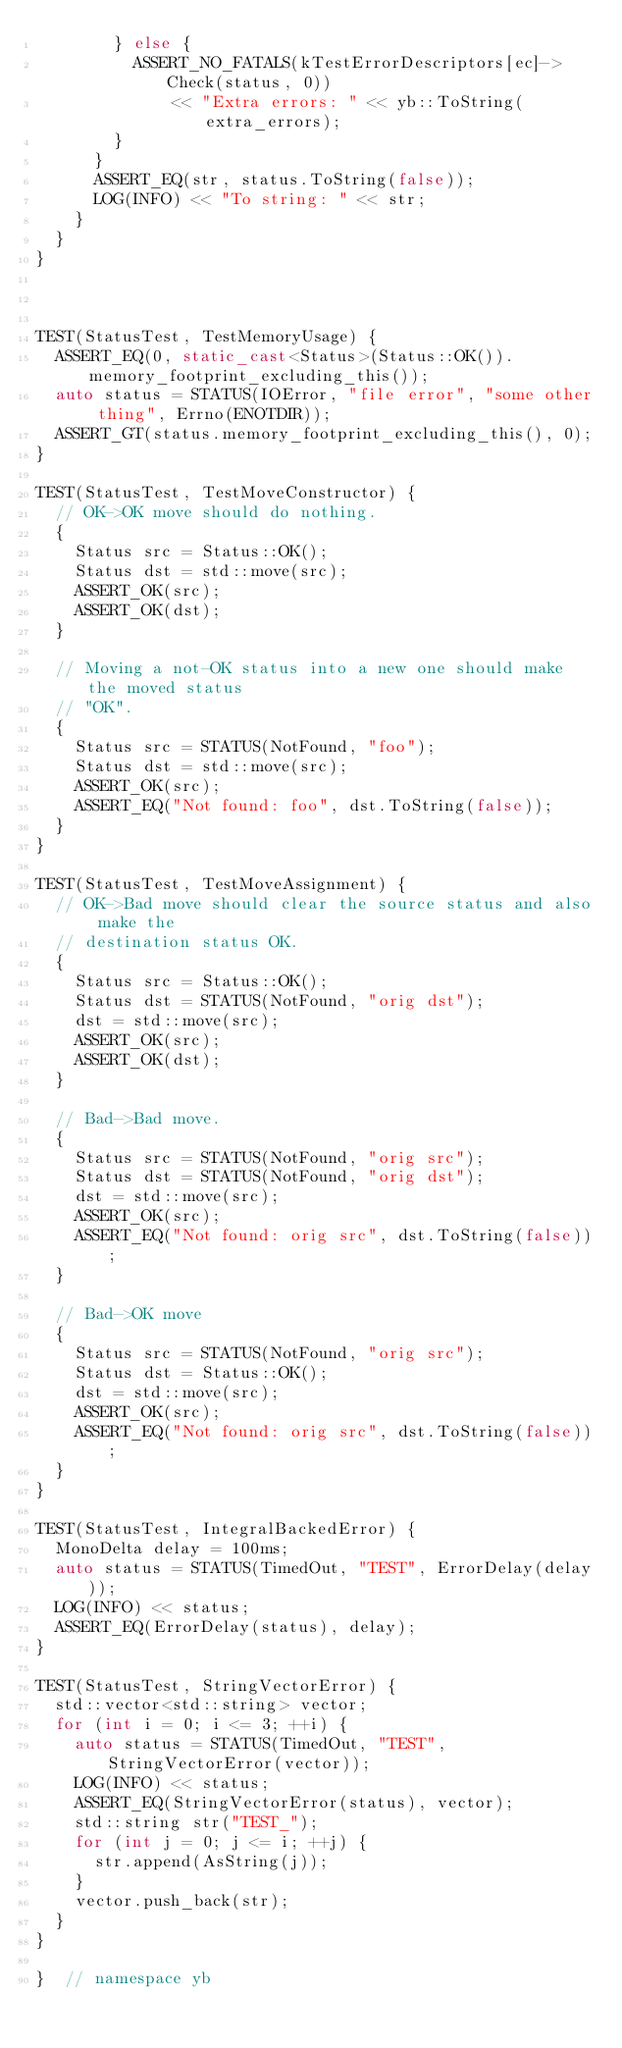<code> <loc_0><loc_0><loc_500><loc_500><_C++_>        } else {
          ASSERT_NO_FATALS(kTestErrorDescriptors[ec]->Check(status, 0))
              << "Extra errors: " << yb::ToString(extra_errors);
        }
      }
      ASSERT_EQ(str, status.ToString(false));
      LOG(INFO) << "To string: " << str;
    }
  }
}



TEST(StatusTest, TestMemoryUsage) {
  ASSERT_EQ(0, static_cast<Status>(Status::OK()).memory_footprint_excluding_this());
  auto status = STATUS(IOError, "file error", "some other thing", Errno(ENOTDIR));
  ASSERT_GT(status.memory_footprint_excluding_this(), 0);
}

TEST(StatusTest, TestMoveConstructor) {
  // OK->OK move should do nothing.
  {
    Status src = Status::OK();
    Status dst = std::move(src);
    ASSERT_OK(src);
    ASSERT_OK(dst);
  }

  // Moving a not-OK status into a new one should make the moved status
  // "OK".
  {
    Status src = STATUS(NotFound, "foo");
    Status dst = std::move(src);
    ASSERT_OK(src);
    ASSERT_EQ("Not found: foo", dst.ToString(false));
  }
}

TEST(StatusTest, TestMoveAssignment) {
  // OK->Bad move should clear the source status and also make the
  // destination status OK.
  {
    Status src = Status::OK();
    Status dst = STATUS(NotFound, "orig dst");
    dst = std::move(src);
    ASSERT_OK(src);
    ASSERT_OK(dst);
  }

  // Bad->Bad move.
  {
    Status src = STATUS(NotFound, "orig src");
    Status dst = STATUS(NotFound, "orig dst");
    dst = std::move(src);
    ASSERT_OK(src);
    ASSERT_EQ("Not found: orig src", dst.ToString(false));
  }

  // Bad->OK move
  {
    Status src = STATUS(NotFound, "orig src");
    Status dst = Status::OK();
    dst = std::move(src);
    ASSERT_OK(src);
    ASSERT_EQ("Not found: orig src", dst.ToString(false));
  }
}

TEST(StatusTest, IntegralBackedError) {
  MonoDelta delay = 100ms;
  auto status = STATUS(TimedOut, "TEST", ErrorDelay(delay));
  LOG(INFO) << status;
  ASSERT_EQ(ErrorDelay(status), delay);
}

TEST(StatusTest, StringVectorError) {
  std::vector<std::string> vector;
  for (int i = 0; i <= 3; ++i) {
    auto status = STATUS(TimedOut, "TEST", StringVectorError(vector));
    LOG(INFO) << status;
    ASSERT_EQ(StringVectorError(status), vector);
    std::string str("TEST_");
    for (int j = 0; j <= i; ++j) {
      str.append(AsString(j));
    }
    vector.push_back(str);
  }
}

}  // namespace yb
</code> 